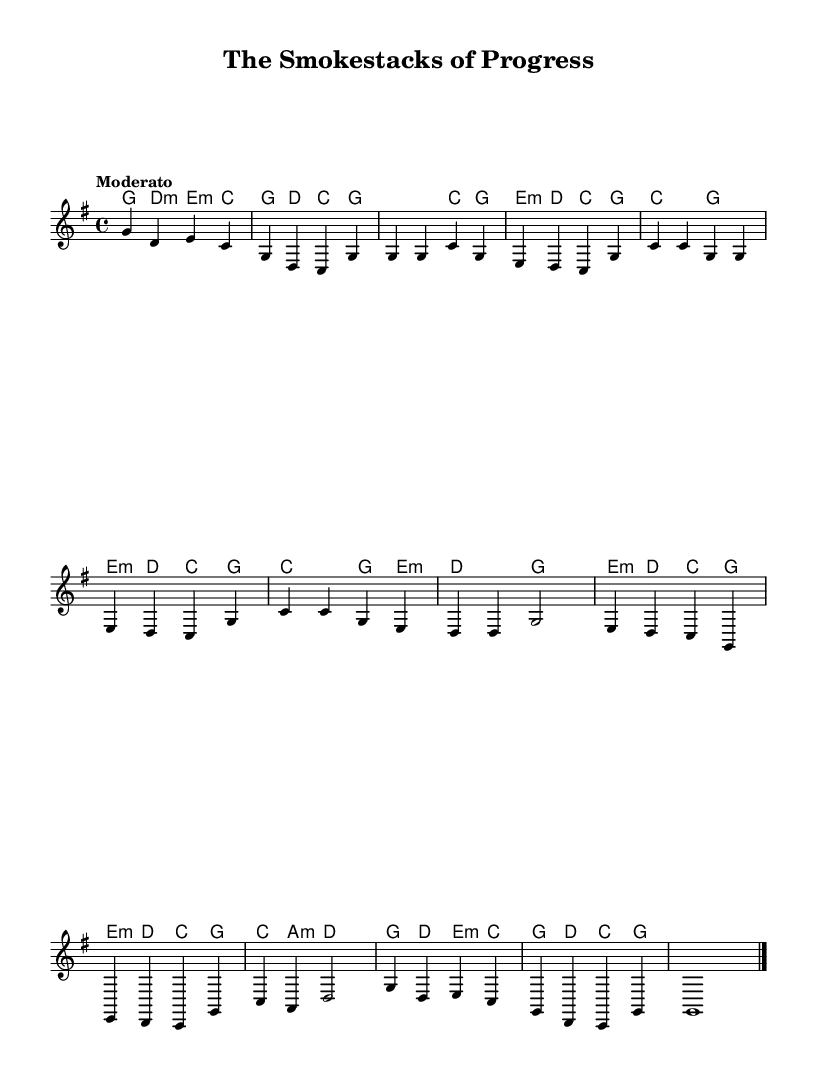What is the key signature of this music? The key signature is G major, which has one sharp (F#).
Answer: G major What is the time signature of this music? The time signature is 4/4, indicating four beats in each measure.
Answer: 4/4 What is the tempo indication given in the music? The tempo indication is "Moderato," which typically means a moderate speed, often interpreted as around 108-120 beats per minute.
Answer: Moderato What is the first chord in the piece? The first chord is G major, as indicated in the chord line at the introduction.
Answer: G How many measures are present in the Chorus section? The Chorus contains four measures, as observed in the melody and chord lines.
Answer: 4 Which section of the song contains a bridge? The bridge section is between the Chorus and the Outro, indicated by a unique set of chords and melody lines.
Answer: Bridge What kind of themes are reflected in this Folk ballad? The themes reflect industrialization and economic progress, emphasizing the positive impacts of such developments.
Answer: Industrialization 